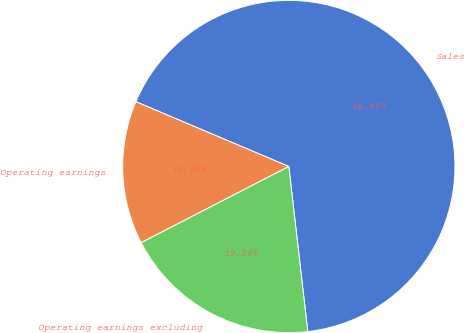Convert chart to OTSL. <chart><loc_0><loc_0><loc_500><loc_500><pie_chart><fcel>Sales<fcel>Operating earnings<fcel>Operating earnings excluding<nl><fcel>66.8%<fcel>13.96%<fcel>19.24%<nl></chart> 